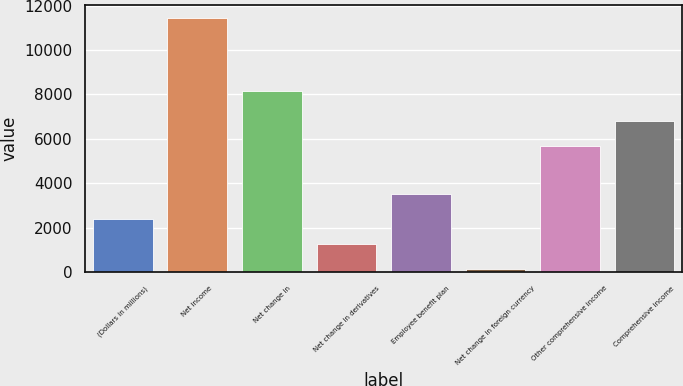Convert chart. <chart><loc_0><loc_0><loc_500><loc_500><bar_chart><fcel>(Dollars in millions)<fcel>Net income<fcel>Net change in<fcel>Net change in derivatives<fcel>Employee benefit plan<fcel>Net change in foreign currency<fcel>Other comprehensive income<fcel>Comprehensive income<nl><fcel>2394.2<fcel>11431<fcel>8166<fcel>1264.6<fcel>3523.8<fcel>135<fcel>5660<fcel>6789.6<nl></chart> 